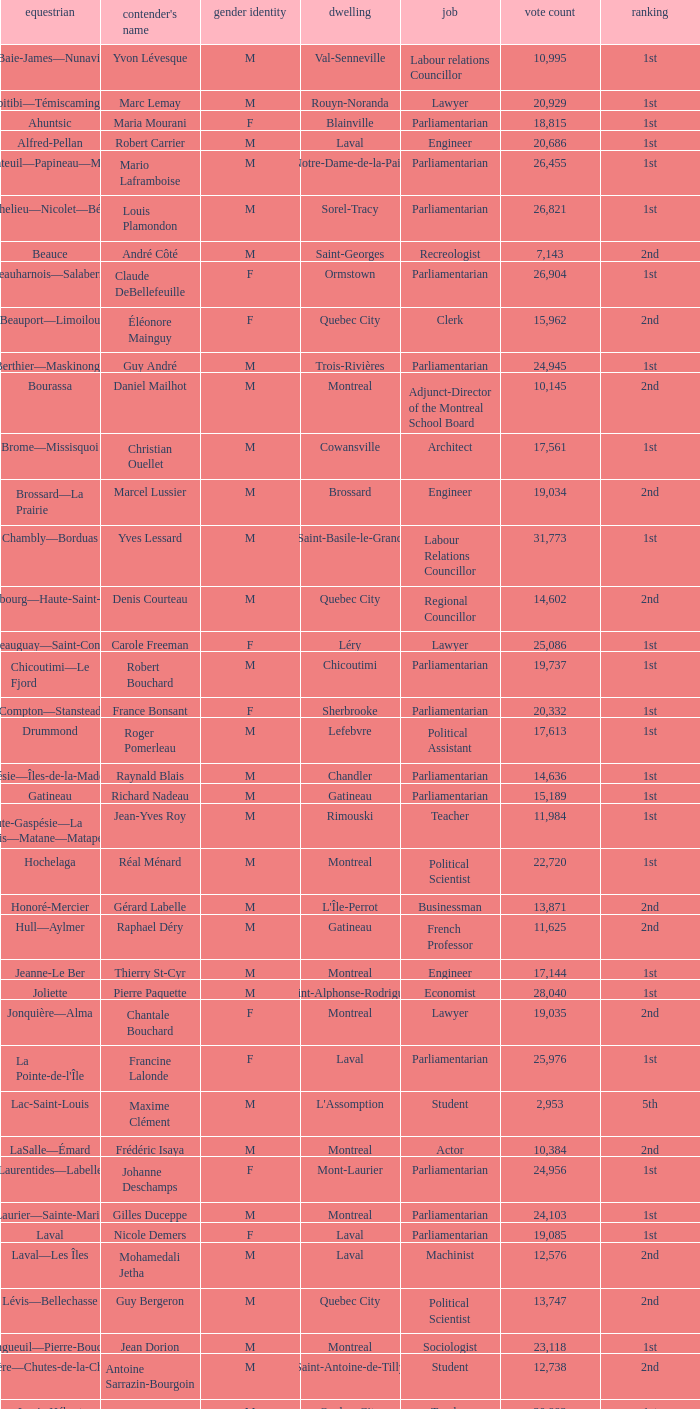What is the highest number of votes for the French Professor? 11625.0. 